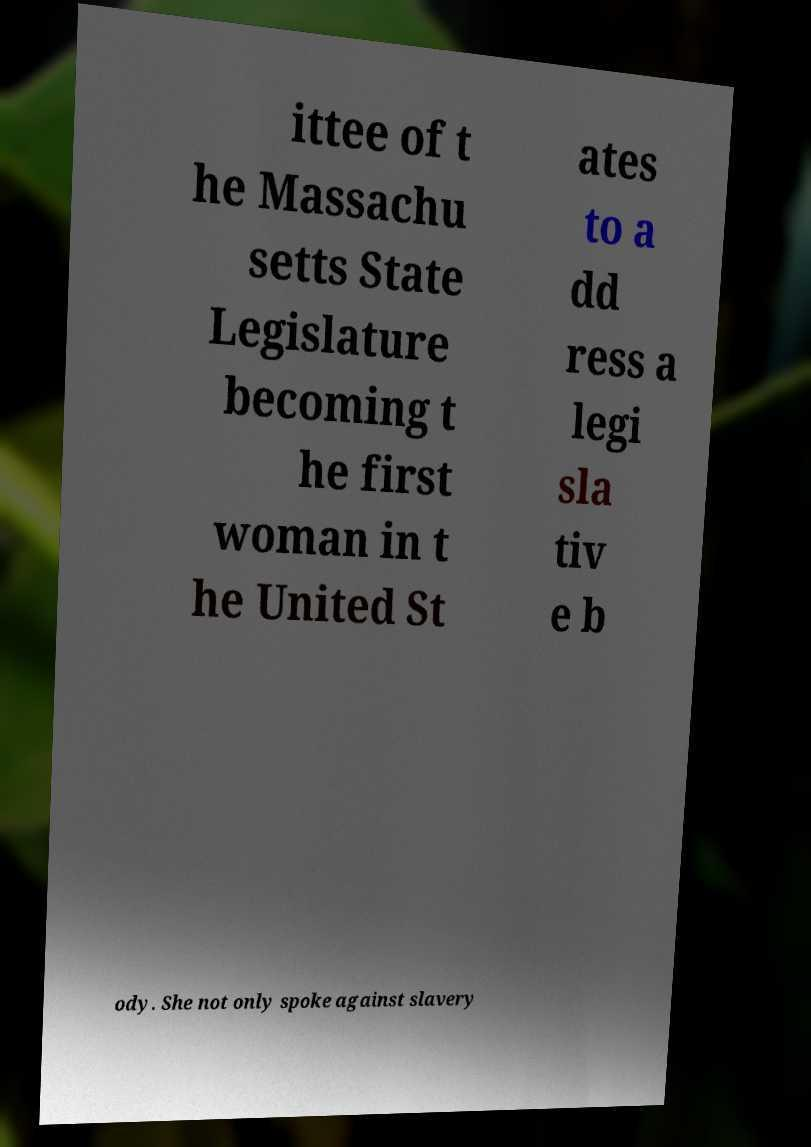I need the written content from this picture converted into text. Can you do that? ittee of t he Massachu setts State Legislature becoming t he first woman in t he United St ates to a dd ress a legi sla tiv e b ody. She not only spoke against slavery 